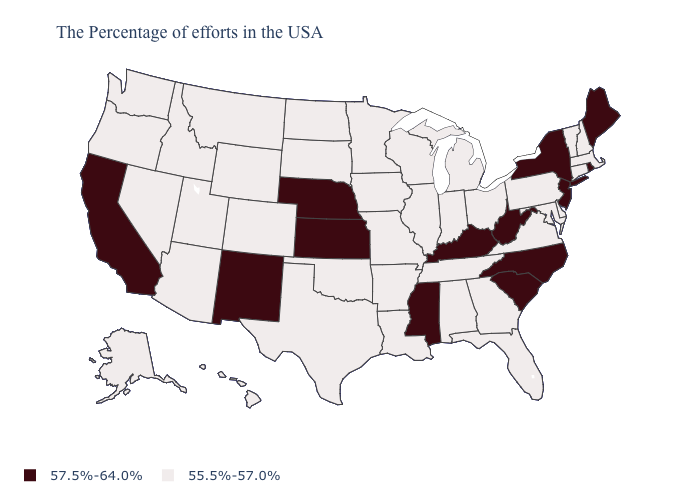Is the legend a continuous bar?
Concise answer only. No. Does Montana have a lower value than Wisconsin?
Concise answer only. No. What is the value of Oklahoma?
Concise answer only. 55.5%-57.0%. Which states have the lowest value in the MidWest?
Write a very short answer. Ohio, Michigan, Indiana, Wisconsin, Illinois, Missouri, Minnesota, Iowa, South Dakota, North Dakota. What is the lowest value in the MidWest?
Be succinct. 55.5%-57.0%. What is the value of New York?
Keep it brief. 57.5%-64.0%. Does Kansas have a higher value than Maryland?
Answer briefly. Yes. What is the value of Iowa?
Keep it brief. 55.5%-57.0%. Name the states that have a value in the range 55.5%-57.0%?
Answer briefly. Massachusetts, New Hampshire, Vermont, Connecticut, Delaware, Maryland, Pennsylvania, Virginia, Ohio, Florida, Georgia, Michigan, Indiana, Alabama, Tennessee, Wisconsin, Illinois, Louisiana, Missouri, Arkansas, Minnesota, Iowa, Oklahoma, Texas, South Dakota, North Dakota, Wyoming, Colorado, Utah, Montana, Arizona, Idaho, Nevada, Washington, Oregon, Alaska, Hawaii. Among the states that border New York , does Vermont have the lowest value?
Answer briefly. Yes. Name the states that have a value in the range 55.5%-57.0%?
Concise answer only. Massachusetts, New Hampshire, Vermont, Connecticut, Delaware, Maryland, Pennsylvania, Virginia, Ohio, Florida, Georgia, Michigan, Indiana, Alabama, Tennessee, Wisconsin, Illinois, Louisiana, Missouri, Arkansas, Minnesota, Iowa, Oklahoma, Texas, South Dakota, North Dakota, Wyoming, Colorado, Utah, Montana, Arizona, Idaho, Nevada, Washington, Oregon, Alaska, Hawaii. Among the states that border New York , does New Jersey have the lowest value?
Be succinct. No. What is the value of Washington?
Write a very short answer. 55.5%-57.0%. Which states have the lowest value in the USA?
Give a very brief answer. Massachusetts, New Hampshire, Vermont, Connecticut, Delaware, Maryland, Pennsylvania, Virginia, Ohio, Florida, Georgia, Michigan, Indiana, Alabama, Tennessee, Wisconsin, Illinois, Louisiana, Missouri, Arkansas, Minnesota, Iowa, Oklahoma, Texas, South Dakota, North Dakota, Wyoming, Colorado, Utah, Montana, Arizona, Idaho, Nevada, Washington, Oregon, Alaska, Hawaii. Which states have the highest value in the USA?
Write a very short answer. Maine, Rhode Island, New York, New Jersey, North Carolina, South Carolina, West Virginia, Kentucky, Mississippi, Kansas, Nebraska, New Mexico, California. 